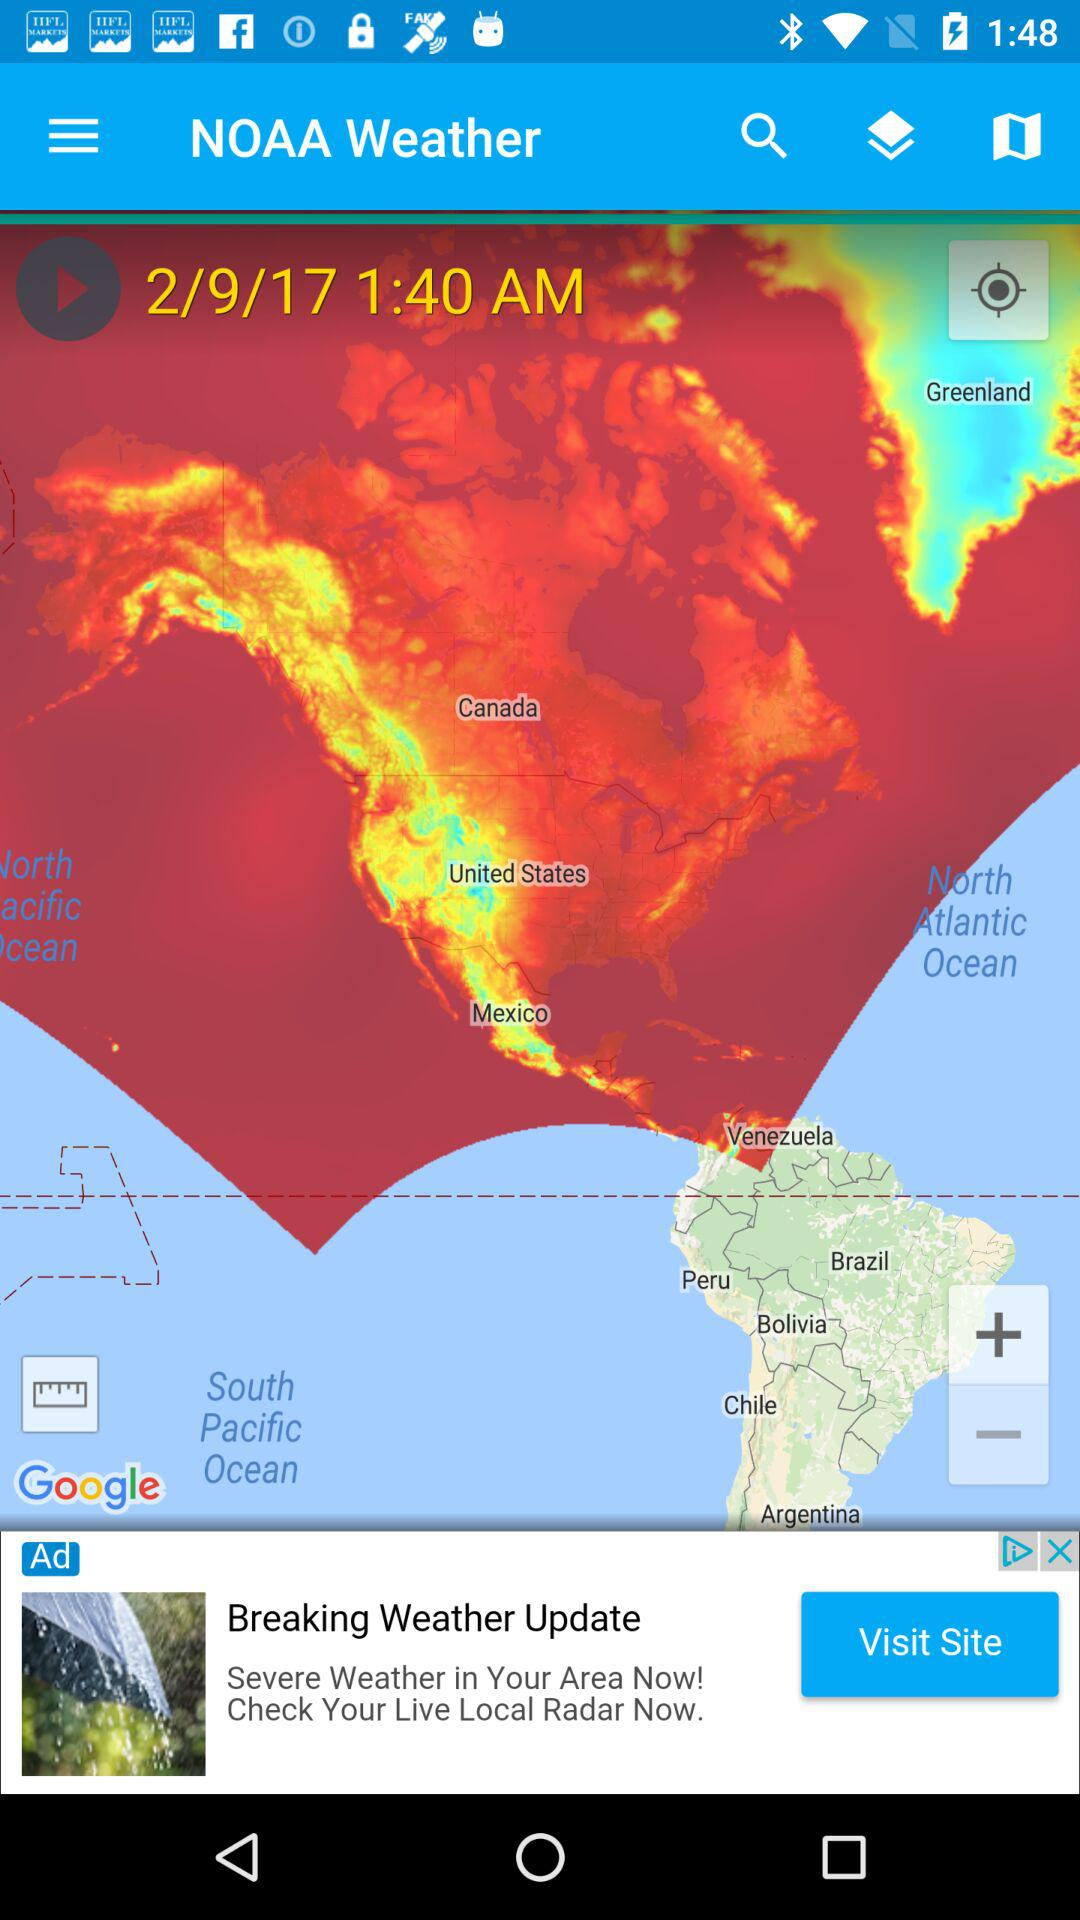Which day of the week is it?
When the provided information is insufficient, respond with <no answer>. <no answer> 